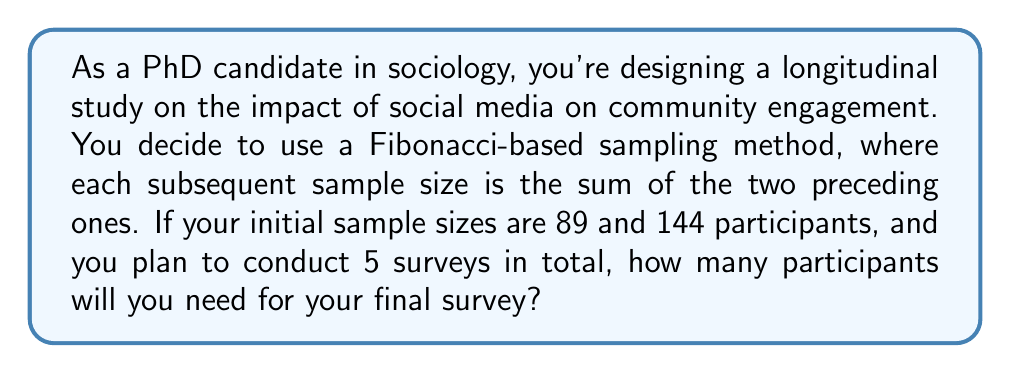Teach me how to tackle this problem. Let's approach this step-by-step using the Fibonacci sequence principle:

1) The Fibonacci sequence is defined as:
   $$F_n = F_{n-1} + F_{n-2}$$
   where $F_n$ is the nth term in the sequence.

2) We're given the first two sample sizes:
   $$F_1 = 89$$
   $$F_2 = 144$$

3) We need to calculate the next three terms in the sequence:

   For the 3rd survey:
   $$F_3 = F_2 + F_1 = 144 + 89 = 233$$

   For the 4th survey:
   $$F_4 = F_3 + F_2 = 233 + 144 = 377$$

   For the 5th survey (our final survey):
   $$F_5 = F_4 + F_3 = 377 + 233 = 610$$

4) Therefore, the sample size for the final (5th) survey will be 610 participants.

This Fibonacci-based approach allows for a structured increase in sample size, which can be beneficial in longitudinal studies to account for potential attrition while maintaining statistical power.
Answer: 610 participants 